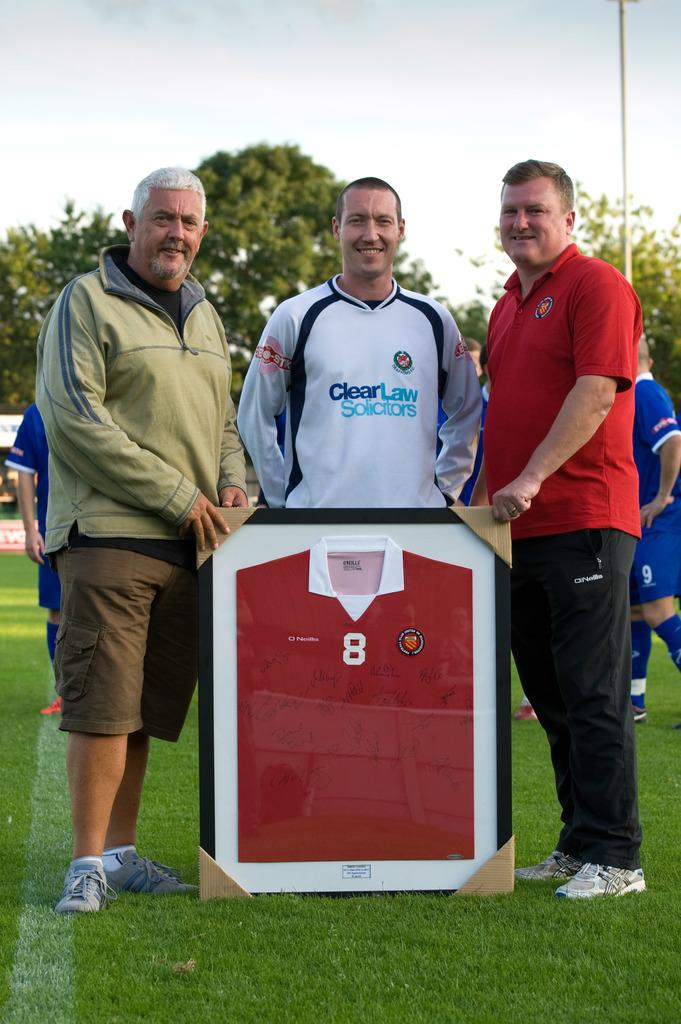Provide a one-sentence caption for the provided image. Three men stand besides a framed jersey with number 8 on the front. 